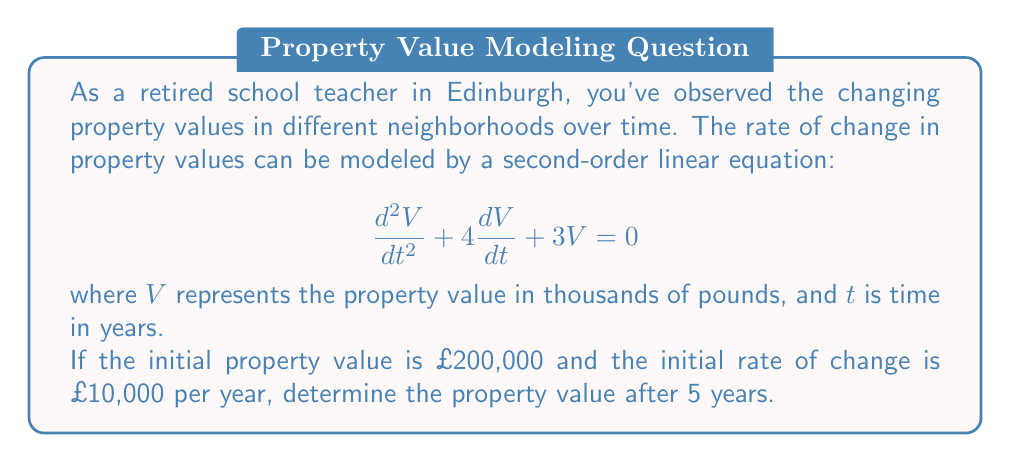Provide a solution to this math problem. 1) First, we need to solve the characteristic equation:
   $$r^2 + 4r + 3 = 0$$
   $$(r + 1)(r + 3) = 0$$
   $$r_1 = -1, r_2 = -3$$

2) The general solution is:
   $$V(t) = c_1e^{-t} + c_2e^{-3t}$$

3) We have two initial conditions:
   $V(0) = 200$ (initial value in thousands)
   $V'(0) = 10$ (initial rate of change in thousands per year)

4) Let's find $c_1$ and $c_2$:
   $V(0) = c_1 + c_2 = 200$
   $V'(t) = -c_1e^{-t} - 3c_2e^{-3t}$
   $V'(0) = -c_1 - 3c_2 = 10$

5) Solving these equations:
   $c_1 = 170$, $c_2 = 30$

6) Therefore, the particular solution is:
   $$V(t) = 170e^{-t} + 30e^{-3t}$$

7) To find the value after 5 years, we calculate $V(5)$:
   $$V(5) = 170e^{-5} + 30e^{-15}$$
   $$V(5) \approx 11.37 + 0.00 \approx 11.37$$

8) Remember to convert back to pounds:
   $11.37 * 1000 = £11,370$
Answer: £11,370 